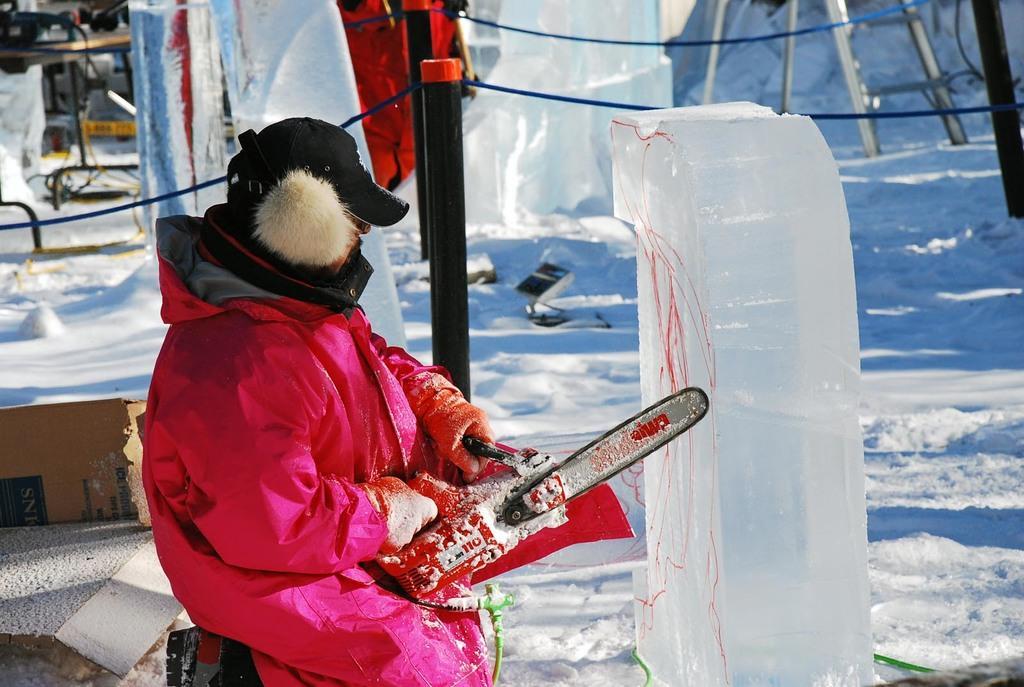Describe this image in one or two sentences. In this image we can see a person wearing pink color jacket, cap and shoes is holding chain saw and cutting the ice. In the background, we can see the fence, ladder and a few more objects. 